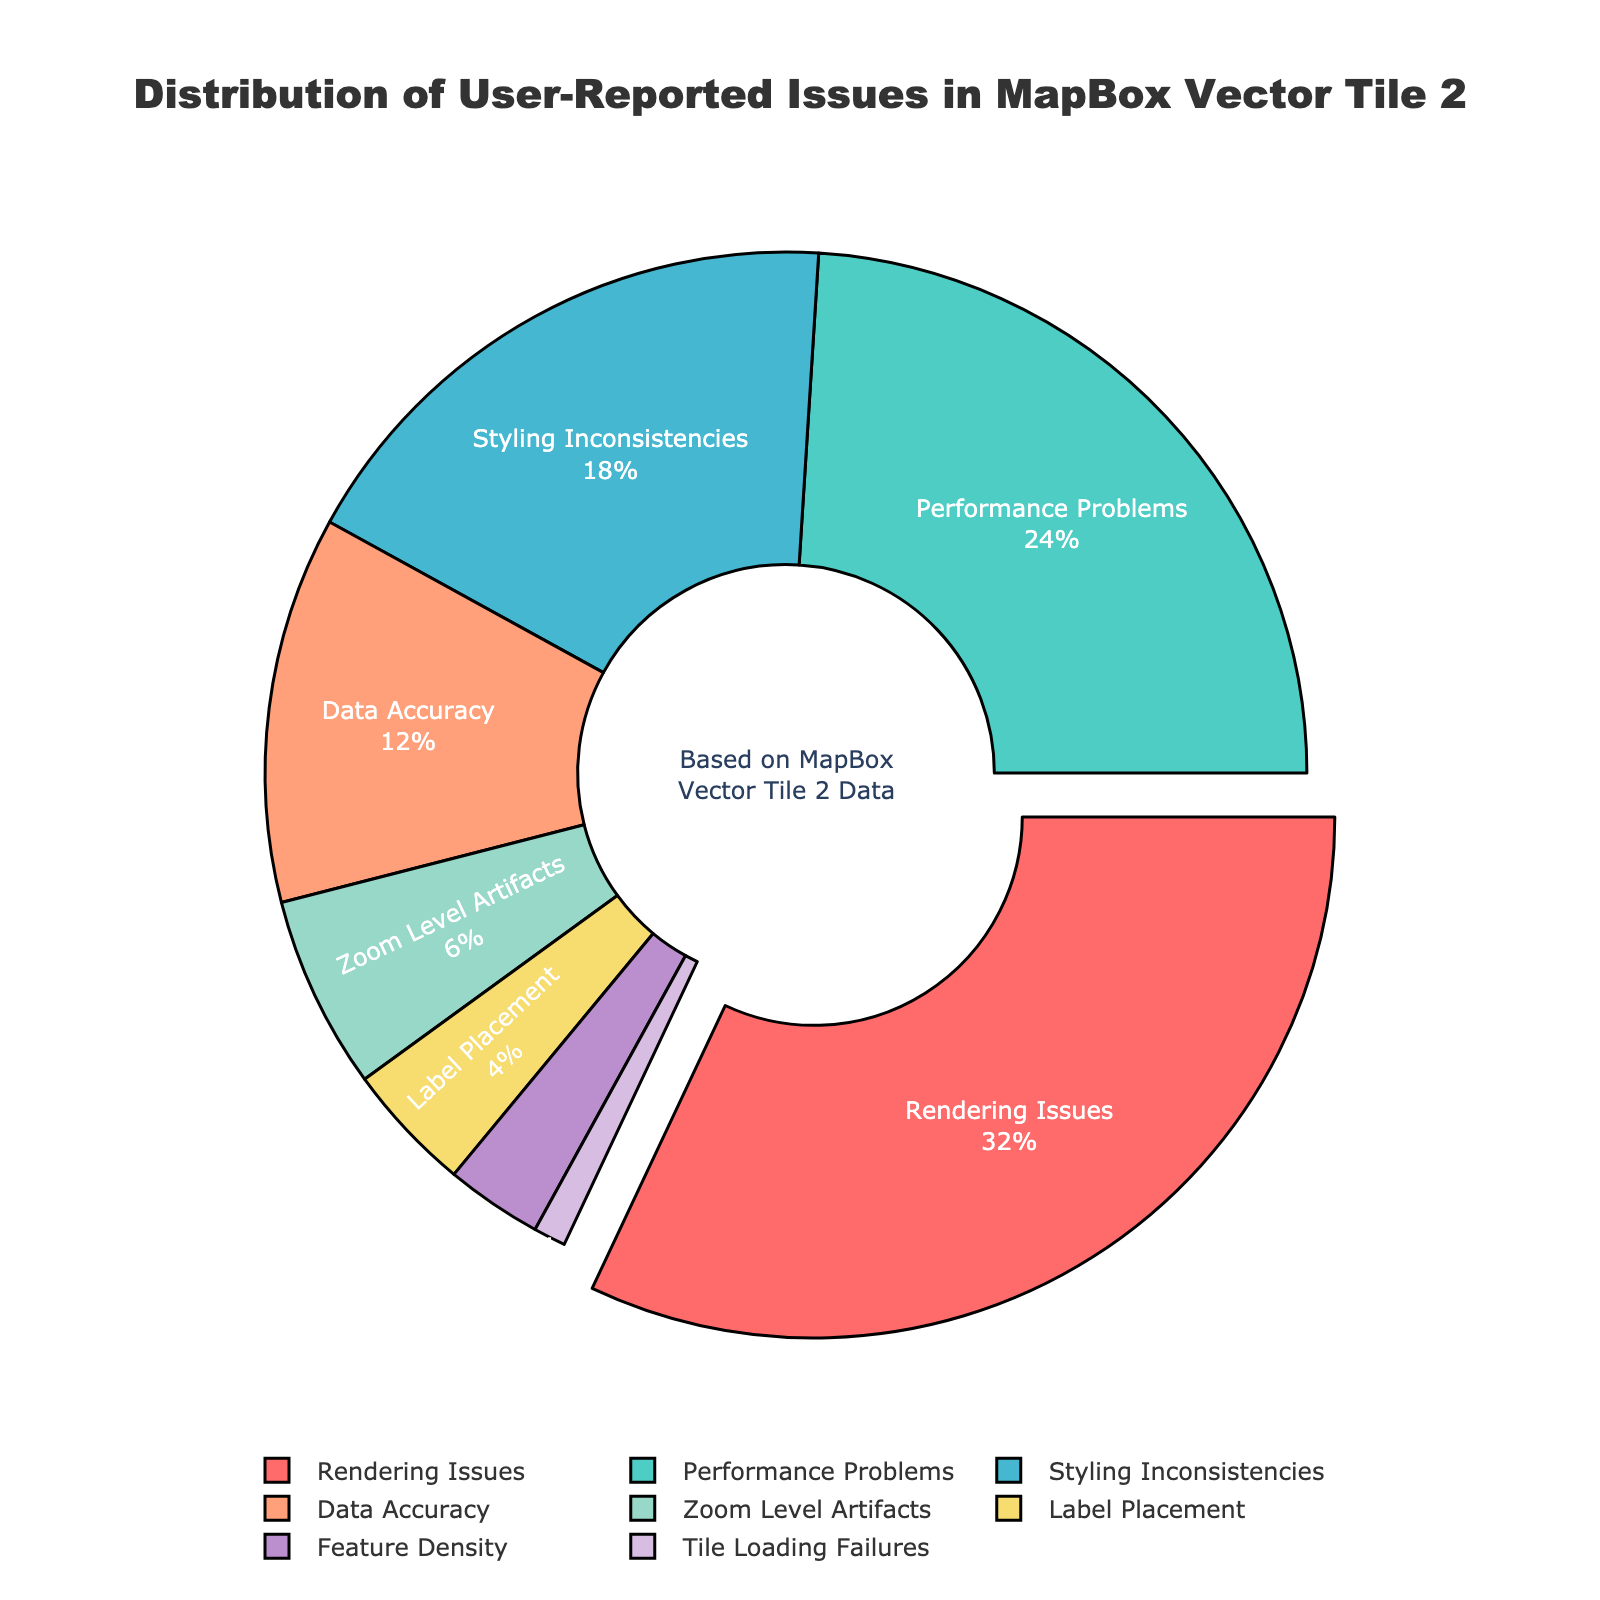What percentage do Rendering Issues represent in the data? Rendering Issues make up 32% as shown in the pie chart.
Answer: 32% Which category has the smallest percentage of user-reported issues? Tile Loading Failures has the smallest percentage, which is 1%.
Answer: Tile Loading Failures What is the combined percentage of Performance Problems and Styling Inconsistencies? Adding the percentages of Performance Problems (24%) and Styling Inconsistencies (18%) results in a combined percentage of 42%.
Answer: 42% What is the difference in percentage between Rendering Issues and Data Accuracy? Subtracting the percentage of Data Accuracy (12%) from Rendering Issues (32%) gives a difference of 20%.
Answer: 20% Is the percentage of Zoom Level Artifacts greater than or less than the percentage of Label Placement? The percentage of Zoom Level Artifacts (6%) is greater than that of Label Placement (4%).
Answer: Greater Which category is depicted in red, and what percentage does it represent? Rendering Issues is the category depicted in red and it represents 32%.
Answer: Rendering Issues, 32% How does the percentage of Feature Density compare to that of Zoom Level Artifacts? The percentage of Feature Density (3%) is half of Zoom Level Artifacts (6%).
Answer: Half What is the average percentage of the categories with less than 10% user-reported issues? The categories with less than 10% are Zoom Level Artifacts (6%), Label Placement (4%), Feature Density (3%), and Tile Loading Failures (1%). Their total is 6 + 4 + 3 + 1 = 14, and the average is 14/4 = 3.5%.
Answer: 3.5% Which category is highlighted by being pulled out from the pie chart and why? Rendering Issues is highlighted by being pulled out as it has the highest percentage (32%).
Answer: Rendering Issues If we combine the percentages of the three least reported categories, what percentage of user-reported issues would this represent? The three least reported categories are Tile Loading Failures (1%), Feature Density (3%), and Label Placement (4%). Their combined percentage is 1 + 3 + 4 = 8%.
Answer: 8% 